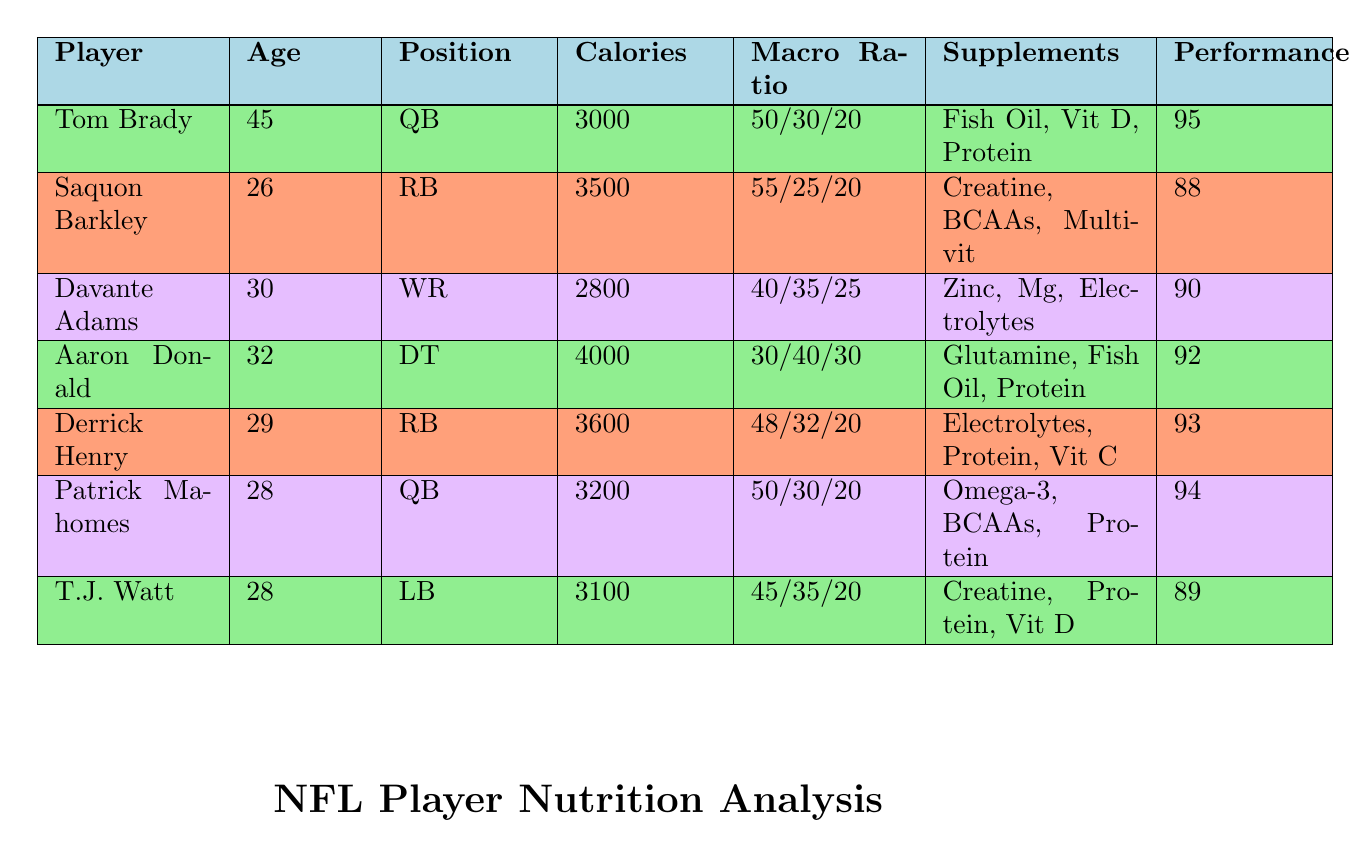What is the caloric intake of Aaron Donald? Aaron Donald's caloric intake can be found directly in the table under the corresponding column, which states that it is 4000.
Answer: 4000 How many players have a performance rating of 90 or higher? By reviewing all the performance ratings in the table, we find that Tom Brady (95), Aaron Donald (92), Derrick Henry (93), and Patrick Mahomes (94) all have ratings of 90 or higher. This gives us a total of 4 players.
Answer: 4 What is the average caloric intake of all players listed in the table? To find this, we add up the caloric intakes: 3000 + 3500 + 2800 + 4000 + 3600 + 3200 + 3100 = 22800. There are 7 players, so we divide 22800 by 7, which is 3257.14, and rounding it gives us 3257.
Answer: 3257 Is it true that all players who supplement with creatine have a performance rating higher than 90? The players that take creatine are Saquon Barkley (88) and T.J. Watt (89), both of whom have ratings below 90. Therefore, the statement is false.
Answer: No Which player has the highest caloric intake and what is their position? Looking at the caloric intakes in the table, Aaron Donald has the highest intake at 4000 calories. His position is Defensive Tackle.
Answer: Defensive Tackle What is the macronutrient ratio for the player with the lowest performance rating? The player with the lowest performance rating is Saquon Barkley with a rating of 88. His macronutrient ratio is 55% carbs, 25% protein, and 20% fats.
Answer: 55/25/20 How does Tom Brady's protein percentage compare to that of Derrick Henry? Tom Brady's protein percentage is 30%, whereas Derrick Henry's is 32%. Therefore, Derrick Henry has a higher protein percentage than Tom Brady by 2%.
Answer: Derrick Henry Do quarterbacks generally have higher performance ratings than running backs in this data? In this data, both quarterbacks (Tom Brady and Patrick Mahomes) have ratings above 90 (95 and 94 respectively), while the running backs (Saquon Barkley and Derrick Henry) have ratings below 90 (88 and 93 respectively). Since Saquon is lower than both quarterbacks, the general statement holds.
Answer: Yes Which supplements does Davante Adams take? From the table, Davante Adams takes Zinc, Magnesium, and Electrolyte Powder, which are listed under the supplements column for him.
Answer: Zinc, Magnesium, Electrolyte Powder 